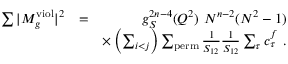<formula> <loc_0><loc_0><loc_500><loc_500>\begin{array} { r l r } { \sum | M _ { g } ^ { v i o l } | ^ { 2 } } & { = } & { g _ { S } ^ { 2 n - 4 } ( Q ^ { 2 } ) N ^ { n - 2 } ( N ^ { 2 } - 1 ) } \\ & { \times \left ( \sum _ { i < j } \right ) \sum _ { p e r m } \frac { 1 } { S _ { 1 2 } } \frac { 1 } { S _ { 1 2 } } \sum _ { \tau } c _ { \tau } ^ { f } . } \end{array}</formula> 